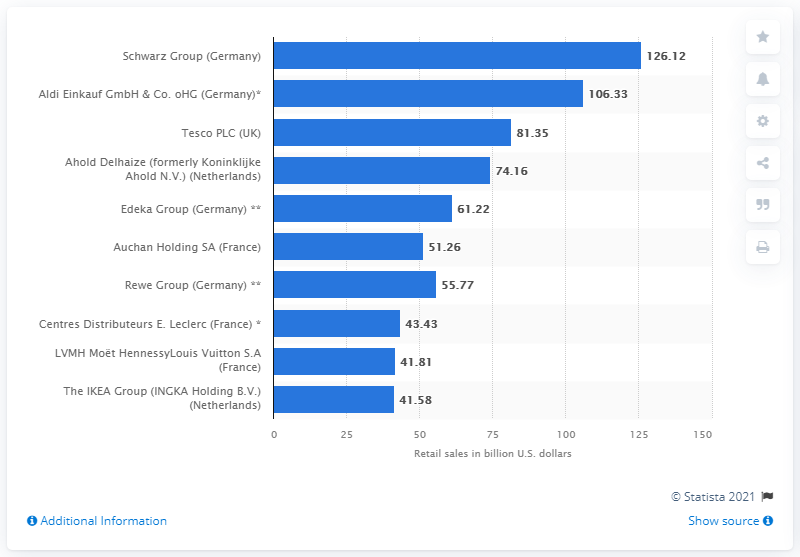Indicate a few pertinent items in this graphic. In 2019, Schwarz generated a total of $126.12 million in sales in the United States. 